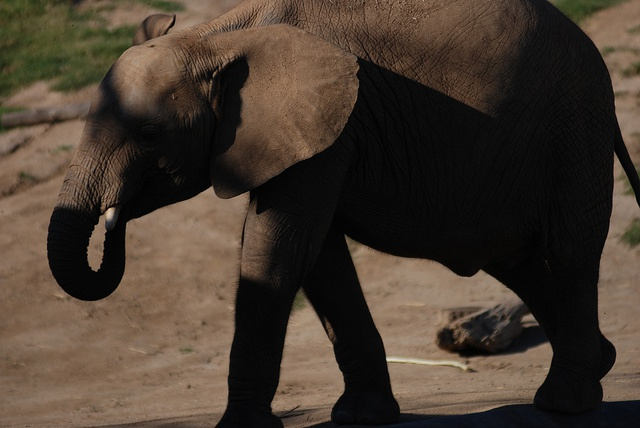Describe the objects in this image and their specific colors. I can see a elephant in darkgreen, black, maroon, and gray tones in this image. 